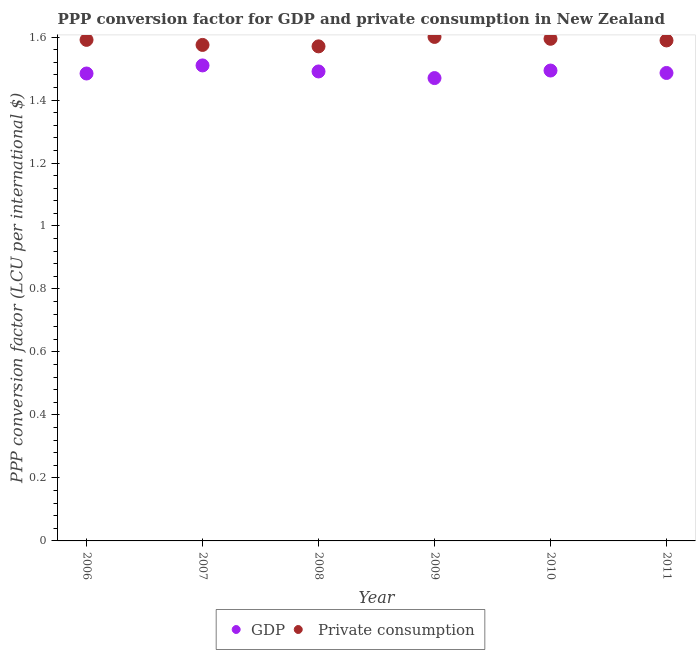Is the number of dotlines equal to the number of legend labels?
Provide a short and direct response. Yes. What is the ppp conversion factor for gdp in 2009?
Your answer should be compact. 1.47. Across all years, what is the maximum ppp conversion factor for private consumption?
Make the answer very short. 1.6. Across all years, what is the minimum ppp conversion factor for gdp?
Your response must be concise. 1.47. In which year was the ppp conversion factor for gdp maximum?
Give a very brief answer. 2007. What is the total ppp conversion factor for gdp in the graph?
Make the answer very short. 8.93. What is the difference between the ppp conversion factor for private consumption in 2008 and that in 2009?
Provide a short and direct response. -0.03. What is the difference between the ppp conversion factor for private consumption in 2007 and the ppp conversion factor for gdp in 2006?
Make the answer very short. 0.09. What is the average ppp conversion factor for private consumption per year?
Offer a very short reply. 1.59. In the year 2010, what is the difference between the ppp conversion factor for private consumption and ppp conversion factor for gdp?
Your answer should be compact. 0.1. What is the ratio of the ppp conversion factor for private consumption in 2009 to that in 2010?
Make the answer very short. 1. Is the ppp conversion factor for private consumption in 2006 less than that in 2011?
Make the answer very short. No. Is the difference between the ppp conversion factor for gdp in 2010 and 2011 greater than the difference between the ppp conversion factor for private consumption in 2010 and 2011?
Give a very brief answer. Yes. What is the difference between the highest and the second highest ppp conversion factor for private consumption?
Your answer should be compact. 0.01. What is the difference between the highest and the lowest ppp conversion factor for gdp?
Provide a short and direct response. 0.04. In how many years, is the ppp conversion factor for private consumption greater than the average ppp conversion factor for private consumption taken over all years?
Provide a succinct answer. 4. Is the sum of the ppp conversion factor for private consumption in 2006 and 2008 greater than the maximum ppp conversion factor for gdp across all years?
Make the answer very short. Yes. Does the ppp conversion factor for private consumption monotonically increase over the years?
Your answer should be compact. No. Is the ppp conversion factor for private consumption strictly greater than the ppp conversion factor for gdp over the years?
Make the answer very short. Yes. Is the ppp conversion factor for gdp strictly less than the ppp conversion factor for private consumption over the years?
Give a very brief answer. Yes. How many years are there in the graph?
Ensure brevity in your answer.  6. How many legend labels are there?
Make the answer very short. 2. What is the title of the graph?
Keep it short and to the point. PPP conversion factor for GDP and private consumption in New Zealand. What is the label or title of the X-axis?
Your response must be concise. Year. What is the label or title of the Y-axis?
Ensure brevity in your answer.  PPP conversion factor (LCU per international $). What is the PPP conversion factor (LCU per international $) of GDP in 2006?
Your answer should be compact. 1.48. What is the PPP conversion factor (LCU per international $) in  Private consumption in 2006?
Provide a succinct answer. 1.59. What is the PPP conversion factor (LCU per international $) of GDP in 2007?
Your answer should be very brief. 1.51. What is the PPP conversion factor (LCU per international $) of  Private consumption in 2007?
Keep it short and to the point. 1.57. What is the PPP conversion factor (LCU per international $) of GDP in 2008?
Ensure brevity in your answer.  1.49. What is the PPP conversion factor (LCU per international $) in  Private consumption in 2008?
Offer a terse response. 1.57. What is the PPP conversion factor (LCU per international $) in GDP in 2009?
Your response must be concise. 1.47. What is the PPP conversion factor (LCU per international $) of  Private consumption in 2009?
Give a very brief answer. 1.6. What is the PPP conversion factor (LCU per international $) of GDP in 2010?
Offer a very short reply. 1.49. What is the PPP conversion factor (LCU per international $) of  Private consumption in 2010?
Give a very brief answer. 1.59. What is the PPP conversion factor (LCU per international $) of GDP in 2011?
Make the answer very short. 1.49. What is the PPP conversion factor (LCU per international $) in  Private consumption in 2011?
Offer a terse response. 1.59. Across all years, what is the maximum PPP conversion factor (LCU per international $) in GDP?
Your answer should be compact. 1.51. Across all years, what is the maximum PPP conversion factor (LCU per international $) in  Private consumption?
Your response must be concise. 1.6. Across all years, what is the minimum PPP conversion factor (LCU per international $) in GDP?
Ensure brevity in your answer.  1.47. Across all years, what is the minimum PPP conversion factor (LCU per international $) in  Private consumption?
Your answer should be very brief. 1.57. What is the total PPP conversion factor (LCU per international $) of GDP in the graph?
Your answer should be compact. 8.93. What is the total PPP conversion factor (LCU per international $) of  Private consumption in the graph?
Your response must be concise. 9.52. What is the difference between the PPP conversion factor (LCU per international $) in GDP in 2006 and that in 2007?
Make the answer very short. -0.03. What is the difference between the PPP conversion factor (LCU per international $) in  Private consumption in 2006 and that in 2007?
Your answer should be very brief. 0.02. What is the difference between the PPP conversion factor (LCU per international $) of GDP in 2006 and that in 2008?
Provide a succinct answer. -0.01. What is the difference between the PPP conversion factor (LCU per international $) of  Private consumption in 2006 and that in 2008?
Offer a terse response. 0.02. What is the difference between the PPP conversion factor (LCU per international $) of GDP in 2006 and that in 2009?
Your answer should be compact. 0.01. What is the difference between the PPP conversion factor (LCU per international $) in  Private consumption in 2006 and that in 2009?
Your response must be concise. -0.01. What is the difference between the PPP conversion factor (LCU per international $) of GDP in 2006 and that in 2010?
Make the answer very short. -0.01. What is the difference between the PPP conversion factor (LCU per international $) of  Private consumption in 2006 and that in 2010?
Keep it short and to the point. -0. What is the difference between the PPP conversion factor (LCU per international $) of GDP in 2006 and that in 2011?
Make the answer very short. -0. What is the difference between the PPP conversion factor (LCU per international $) of  Private consumption in 2006 and that in 2011?
Make the answer very short. 0. What is the difference between the PPP conversion factor (LCU per international $) in GDP in 2007 and that in 2008?
Your answer should be very brief. 0.02. What is the difference between the PPP conversion factor (LCU per international $) in  Private consumption in 2007 and that in 2008?
Keep it short and to the point. 0. What is the difference between the PPP conversion factor (LCU per international $) in GDP in 2007 and that in 2009?
Provide a succinct answer. 0.04. What is the difference between the PPP conversion factor (LCU per international $) in  Private consumption in 2007 and that in 2009?
Provide a short and direct response. -0.03. What is the difference between the PPP conversion factor (LCU per international $) of GDP in 2007 and that in 2010?
Offer a very short reply. 0.02. What is the difference between the PPP conversion factor (LCU per international $) of  Private consumption in 2007 and that in 2010?
Provide a succinct answer. -0.02. What is the difference between the PPP conversion factor (LCU per international $) of GDP in 2007 and that in 2011?
Offer a very short reply. 0.02. What is the difference between the PPP conversion factor (LCU per international $) in  Private consumption in 2007 and that in 2011?
Ensure brevity in your answer.  -0.01. What is the difference between the PPP conversion factor (LCU per international $) in GDP in 2008 and that in 2009?
Provide a succinct answer. 0.02. What is the difference between the PPP conversion factor (LCU per international $) in  Private consumption in 2008 and that in 2009?
Ensure brevity in your answer.  -0.03. What is the difference between the PPP conversion factor (LCU per international $) in GDP in 2008 and that in 2010?
Offer a terse response. -0. What is the difference between the PPP conversion factor (LCU per international $) of  Private consumption in 2008 and that in 2010?
Provide a succinct answer. -0.02. What is the difference between the PPP conversion factor (LCU per international $) in GDP in 2008 and that in 2011?
Make the answer very short. 0. What is the difference between the PPP conversion factor (LCU per international $) in  Private consumption in 2008 and that in 2011?
Give a very brief answer. -0.02. What is the difference between the PPP conversion factor (LCU per international $) in GDP in 2009 and that in 2010?
Your response must be concise. -0.02. What is the difference between the PPP conversion factor (LCU per international $) of  Private consumption in 2009 and that in 2010?
Your answer should be very brief. 0.01. What is the difference between the PPP conversion factor (LCU per international $) in GDP in 2009 and that in 2011?
Make the answer very short. -0.02. What is the difference between the PPP conversion factor (LCU per international $) of  Private consumption in 2009 and that in 2011?
Give a very brief answer. 0.01. What is the difference between the PPP conversion factor (LCU per international $) of GDP in 2010 and that in 2011?
Offer a very short reply. 0.01. What is the difference between the PPP conversion factor (LCU per international $) of  Private consumption in 2010 and that in 2011?
Ensure brevity in your answer.  0.01. What is the difference between the PPP conversion factor (LCU per international $) in GDP in 2006 and the PPP conversion factor (LCU per international $) in  Private consumption in 2007?
Provide a short and direct response. -0.09. What is the difference between the PPP conversion factor (LCU per international $) of GDP in 2006 and the PPP conversion factor (LCU per international $) of  Private consumption in 2008?
Your response must be concise. -0.09. What is the difference between the PPP conversion factor (LCU per international $) of GDP in 2006 and the PPP conversion factor (LCU per international $) of  Private consumption in 2009?
Ensure brevity in your answer.  -0.12. What is the difference between the PPP conversion factor (LCU per international $) of GDP in 2006 and the PPP conversion factor (LCU per international $) of  Private consumption in 2010?
Provide a succinct answer. -0.11. What is the difference between the PPP conversion factor (LCU per international $) of GDP in 2006 and the PPP conversion factor (LCU per international $) of  Private consumption in 2011?
Make the answer very short. -0.1. What is the difference between the PPP conversion factor (LCU per international $) of GDP in 2007 and the PPP conversion factor (LCU per international $) of  Private consumption in 2008?
Your answer should be compact. -0.06. What is the difference between the PPP conversion factor (LCU per international $) of GDP in 2007 and the PPP conversion factor (LCU per international $) of  Private consumption in 2009?
Ensure brevity in your answer.  -0.09. What is the difference between the PPP conversion factor (LCU per international $) in GDP in 2007 and the PPP conversion factor (LCU per international $) in  Private consumption in 2010?
Your response must be concise. -0.08. What is the difference between the PPP conversion factor (LCU per international $) in GDP in 2007 and the PPP conversion factor (LCU per international $) in  Private consumption in 2011?
Give a very brief answer. -0.08. What is the difference between the PPP conversion factor (LCU per international $) of GDP in 2008 and the PPP conversion factor (LCU per international $) of  Private consumption in 2009?
Ensure brevity in your answer.  -0.11. What is the difference between the PPP conversion factor (LCU per international $) of GDP in 2008 and the PPP conversion factor (LCU per international $) of  Private consumption in 2010?
Your response must be concise. -0.1. What is the difference between the PPP conversion factor (LCU per international $) in GDP in 2008 and the PPP conversion factor (LCU per international $) in  Private consumption in 2011?
Your answer should be compact. -0.1. What is the difference between the PPP conversion factor (LCU per international $) of GDP in 2009 and the PPP conversion factor (LCU per international $) of  Private consumption in 2010?
Your answer should be compact. -0.12. What is the difference between the PPP conversion factor (LCU per international $) in GDP in 2009 and the PPP conversion factor (LCU per international $) in  Private consumption in 2011?
Give a very brief answer. -0.12. What is the difference between the PPP conversion factor (LCU per international $) of GDP in 2010 and the PPP conversion factor (LCU per international $) of  Private consumption in 2011?
Provide a succinct answer. -0.1. What is the average PPP conversion factor (LCU per international $) of GDP per year?
Give a very brief answer. 1.49. What is the average PPP conversion factor (LCU per international $) of  Private consumption per year?
Your answer should be very brief. 1.59. In the year 2006, what is the difference between the PPP conversion factor (LCU per international $) of GDP and PPP conversion factor (LCU per international $) of  Private consumption?
Give a very brief answer. -0.11. In the year 2007, what is the difference between the PPP conversion factor (LCU per international $) in GDP and PPP conversion factor (LCU per international $) in  Private consumption?
Your answer should be compact. -0.07. In the year 2008, what is the difference between the PPP conversion factor (LCU per international $) of GDP and PPP conversion factor (LCU per international $) of  Private consumption?
Your response must be concise. -0.08. In the year 2009, what is the difference between the PPP conversion factor (LCU per international $) in GDP and PPP conversion factor (LCU per international $) in  Private consumption?
Make the answer very short. -0.13. In the year 2010, what is the difference between the PPP conversion factor (LCU per international $) of GDP and PPP conversion factor (LCU per international $) of  Private consumption?
Offer a terse response. -0.1. In the year 2011, what is the difference between the PPP conversion factor (LCU per international $) in GDP and PPP conversion factor (LCU per international $) in  Private consumption?
Keep it short and to the point. -0.1. What is the ratio of the PPP conversion factor (LCU per international $) of GDP in 2006 to that in 2007?
Provide a succinct answer. 0.98. What is the ratio of the PPP conversion factor (LCU per international $) of  Private consumption in 2006 to that in 2007?
Provide a short and direct response. 1.01. What is the ratio of the PPP conversion factor (LCU per international $) in  Private consumption in 2006 to that in 2008?
Provide a succinct answer. 1.01. What is the ratio of the PPP conversion factor (LCU per international $) in GDP in 2006 to that in 2009?
Your response must be concise. 1.01. What is the ratio of the PPP conversion factor (LCU per international $) in  Private consumption in 2006 to that in 2009?
Ensure brevity in your answer.  0.99. What is the ratio of the PPP conversion factor (LCU per international $) of GDP in 2006 to that in 2011?
Make the answer very short. 1. What is the ratio of the PPP conversion factor (LCU per international $) in GDP in 2007 to that in 2008?
Provide a short and direct response. 1.01. What is the ratio of the PPP conversion factor (LCU per international $) of GDP in 2007 to that in 2009?
Your answer should be compact. 1.03. What is the ratio of the PPP conversion factor (LCU per international $) of  Private consumption in 2007 to that in 2009?
Offer a very short reply. 0.98. What is the ratio of the PPP conversion factor (LCU per international $) of GDP in 2007 to that in 2010?
Offer a terse response. 1.01. What is the ratio of the PPP conversion factor (LCU per international $) of GDP in 2007 to that in 2011?
Offer a very short reply. 1.02. What is the ratio of the PPP conversion factor (LCU per international $) of  Private consumption in 2007 to that in 2011?
Offer a very short reply. 0.99. What is the ratio of the PPP conversion factor (LCU per international $) of GDP in 2008 to that in 2009?
Your answer should be very brief. 1.01. What is the ratio of the PPP conversion factor (LCU per international $) of  Private consumption in 2008 to that in 2009?
Give a very brief answer. 0.98. What is the ratio of the PPP conversion factor (LCU per international $) in GDP in 2008 to that in 2010?
Provide a succinct answer. 1. What is the ratio of the PPP conversion factor (LCU per international $) of  Private consumption in 2008 to that in 2010?
Your answer should be very brief. 0.98. What is the ratio of the PPP conversion factor (LCU per international $) in GDP in 2009 to that in 2010?
Provide a succinct answer. 0.98. What is the ratio of the PPP conversion factor (LCU per international $) of GDP in 2009 to that in 2011?
Keep it short and to the point. 0.99. What is the ratio of the PPP conversion factor (LCU per international $) of  Private consumption in 2009 to that in 2011?
Your answer should be very brief. 1.01. What is the ratio of the PPP conversion factor (LCU per international $) in  Private consumption in 2010 to that in 2011?
Provide a succinct answer. 1. What is the difference between the highest and the second highest PPP conversion factor (LCU per international $) in GDP?
Keep it short and to the point. 0.02. What is the difference between the highest and the second highest PPP conversion factor (LCU per international $) of  Private consumption?
Provide a short and direct response. 0.01. What is the difference between the highest and the lowest PPP conversion factor (LCU per international $) in GDP?
Your response must be concise. 0.04. What is the difference between the highest and the lowest PPP conversion factor (LCU per international $) of  Private consumption?
Keep it short and to the point. 0.03. 